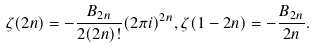<formula> <loc_0><loc_0><loc_500><loc_500>\zeta ( 2 n ) = - \frac { B _ { 2 n } } { 2 ( 2 n ) ! } ( 2 \pi i ) ^ { 2 n } , \zeta ( 1 - 2 n ) = - \frac { B _ { 2 n } } { 2 n } .</formula> 